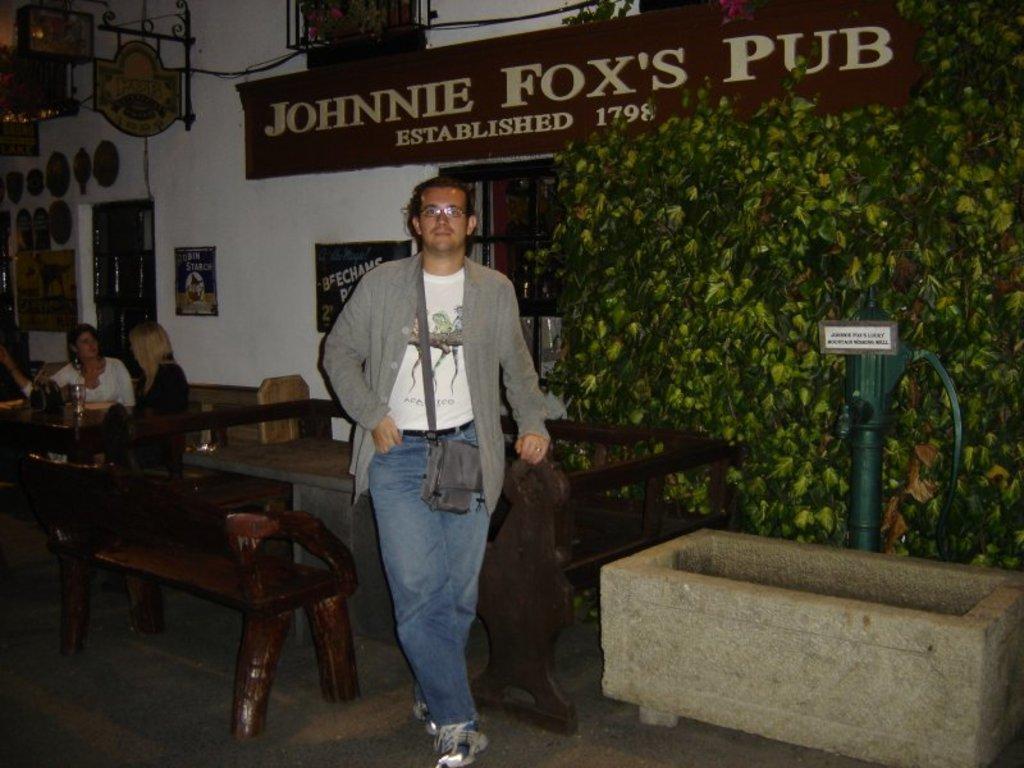How would you summarize this image in a sentence or two? In this picture is a man standing and there is a plant and the name board of wall behind him and their people sitting over here. 